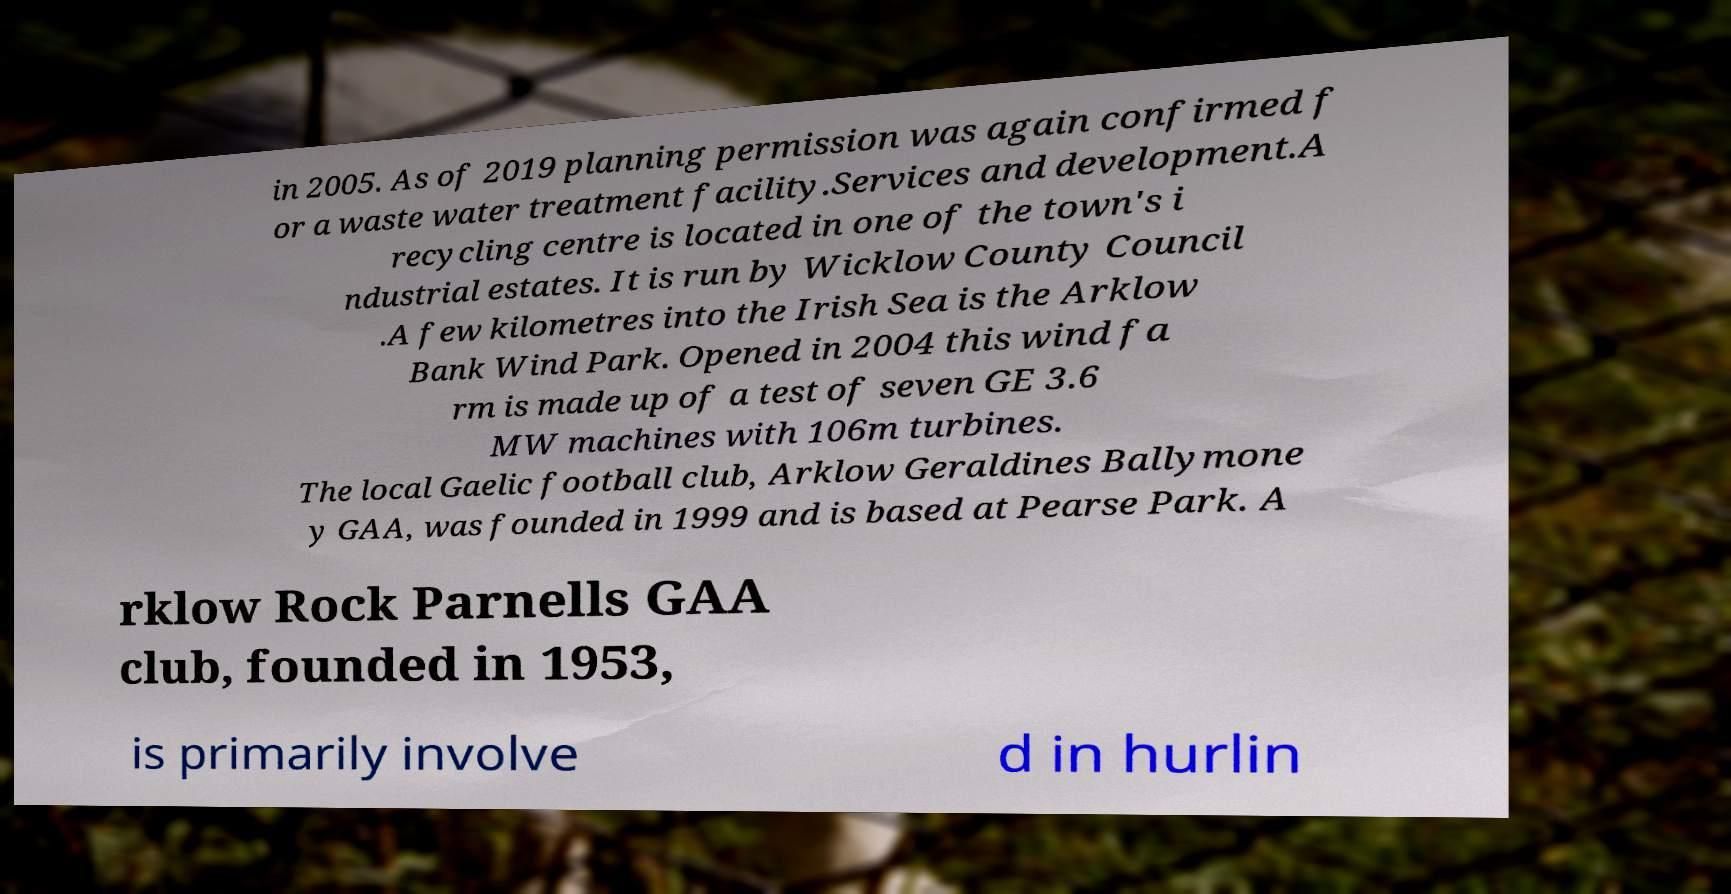What messages or text are displayed in this image? I need them in a readable, typed format. in 2005. As of 2019 planning permission was again confirmed f or a waste water treatment facility.Services and development.A recycling centre is located in one of the town's i ndustrial estates. It is run by Wicklow County Council .A few kilometres into the Irish Sea is the Arklow Bank Wind Park. Opened in 2004 this wind fa rm is made up of a test of seven GE 3.6 MW machines with 106m turbines. The local Gaelic football club, Arklow Geraldines Ballymone y GAA, was founded in 1999 and is based at Pearse Park. A rklow Rock Parnells GAA club, founded in 1953, is primarily involve d in hurlin 